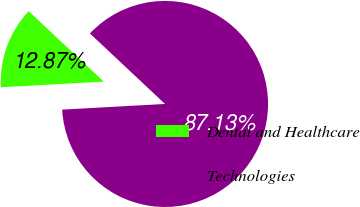Convert chart. <chart><loc_0><loc_0><loc_500><loc_500><pie_chart><fcel>Dental and Healthcare<fcel>Technologies<nl><fcel>12.87%<fcel>87.13%<nl></chart> 